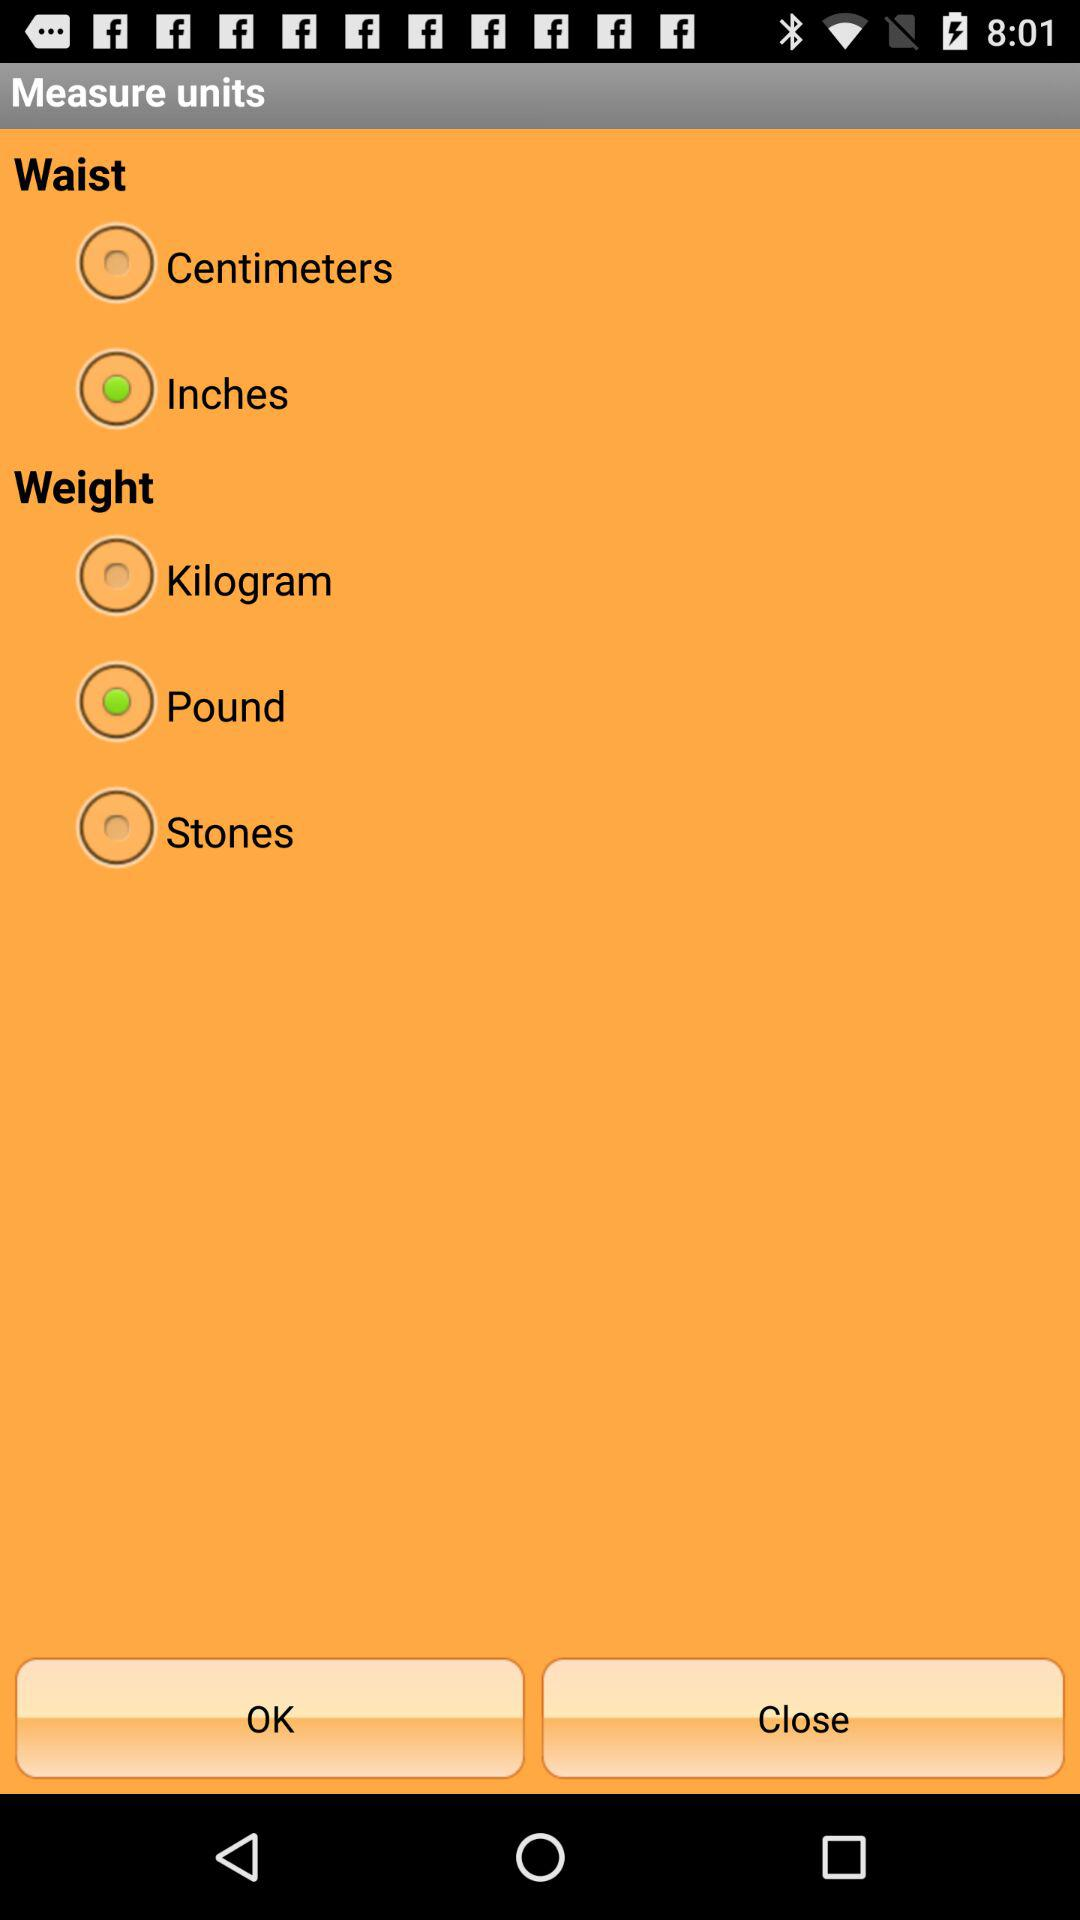What are the different units for measuring weight? The different units for measuring weight are the kilogram, the pound and the stone. 